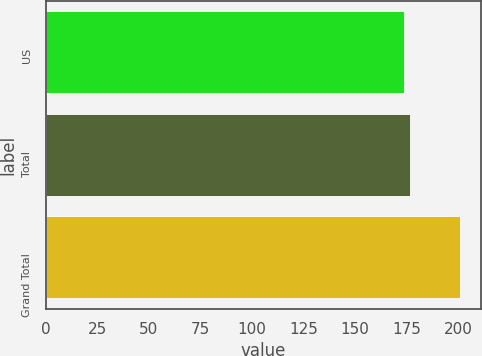Convert chart to OTSL. <chart><loc_0><loc_0><loc_500><loc_500><bar_chart><fcel>US<fcel>Total<fcel>Grand Total<nl><fcel>174<fcel>176.7<fcel>201<nl></chart> 